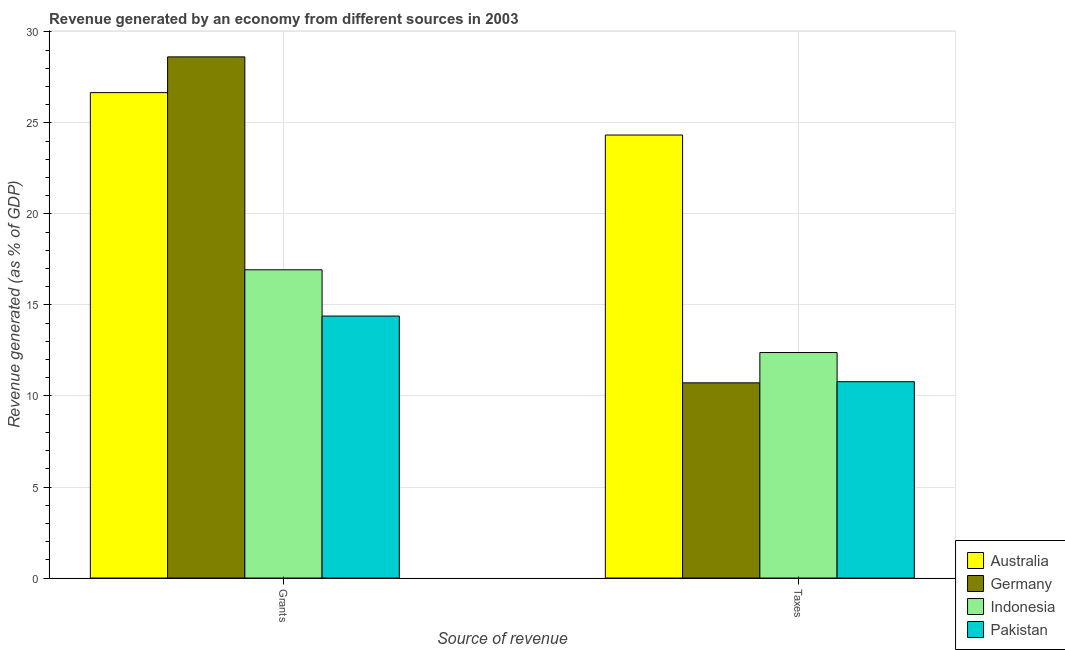How many different coloured bars are there?
Your response must be concise. 4. How many bars are there on the 1st tick from the right?
Make the answer very short. 4. What is the label of the 1st group of bars from the left?
Offer a terse response. Grants. What is the revenue generated by grants in Germany?
Make the answer very short. 28.62. Across all countries, what is the maximum revenue generated by grants?
Offer a very short reply. 28.62. Across all countries, what is the minimum revenue generated by taxes?
Your response must be concise. 10.72. In which country was the revenue generated by grants maximum?
Your response must be concise. Germany. In which country was the revenue generated by taxes minimum?
Provide a short and direct response. Germany. What is the total revenue generated by taxes in the graph?
Make the answer very short. 58.22. What is the difference between the revenue generated by taxes in Germany and that in Pakistan?
Keep it short and to the point. -0.06. What is the difference between the revenue generated by grants in Germany and the revenue generated by taxes in Indonesia?
Your answer should be very brief. 16.24. What is the average revenue generated by taxes per country?
Provide a short and direct response. 14.56. What is the difference between the revenue generated by grants and revenue generated by taxes in Pakistan?
Ensure brevity in your answer.  3.61. In how many countries, is the revenue generated by taxes greater than 16 %?
Offer a terse response. 1. What is the ratio of the revenue generated by taxes in Pakistan to that in Indonesia?
Give a very brief answer. 0.87. In how many countries, is the revenue generated by grants greater than the average revenue generated by grants taken over all countries?
Ensure brevity in your answer.  2. What does the 3rd bar from the left in Grants represents?
Offer a terse response. Indonesia. Are all the bars in the graph horizontal?
Your answer should be compact. No. Are the values on the major ticks of Y-axis written in scientific E-notation?
Provide a succinct answer. No. Does the graph contain any zero values?
Give a very brief answer. No. Does the graph contain grids?
Your answer should be compact. Yes. What is the title of the graph?
Provide a short and direct response. Revenue generated by an economy from different sources in 2003. What is the label or title of the X-axis?
Ensure brevity in your answer.  Source of revenue. What is the label or title of the Y-axis?
Provide a short and direct response. Revenue generated (as % of GDP). What is the Revenue generated (as % of GDP) in Australia in Grants?
Give a very brief answer. 26.66. What is the Revenue generated (as % of GDP) in Germany in Grants?
Your answer should be compact. 28.62. What is the Revenue generated (as % of GDP) in Indonesia in Grants?
Your answer should be very brief. 16.93. What is the Revenue generated (as % of GDP) of Pakistan in Grants?
Provide a short and direct response. 14.39. What is the Revenue generated (as % of GDP) of Australia in Taxes?
Provide a succinct answer. 24.33. What is the Revenue generated (as % of GDP) in Germany in Taxes?
Your answer should be compact. 10.72. What is the Revenue generated (as % of GDP) of Indonesia in Taxes?
Make the answer very short. 12.39. What is the Revenue generated (as % of GDP) in Pakistan in Taxes?
Give a very brief answer. 10.78. Across all Source of revenue, what is the maximum Revenue generated (as % of GDP) in Australia?
Ensure brevity in your answer.  26.66. Across all Source of revenue, what is the maximum Revenue generated (as % of GDP) of Germany?
Give a very brief answer. 28.62. Across all Source of revenue, what is the maximum Revenue generated (as % of GDP) in Indonesia?
Your answer should be compact. 16.93. Across all Source of revenue, what is the maximum Revenue generated (as % of GDP) in Pakistan?
Offer a very short reply. 14.39. Across all Source of revenue, what is the minimum Revenue generated (as % of GDP) in Australia?
Your answer should be very brief. 24.33. Across all Source of revenue, what is the minimum Revenue generated (as % of GDP) of Germany?
Keep it short and to the point. 10.72. Across all Source of revenue, what is the minimum Revenue generated (as % of GDP) of Indonesia?
Keep it short and to the point. 12.39. Across all Source of revenue, what is the minimum Revenue generated (as % of GDP) in Pakistan?
Keep it short and to the point. 10.78. What is the total Revenue generated (as % of GDP) of Australia in the graph?
Provide a short and direct response. 50.99. What is the total Revenue generated (as % of GDP) in Germany in the graph?
Your answer should be compact. 39.35. What is the total Revenue generated (as % of GDP) of Indonesia in the graph?
Provide a succinct answer. 29.32. What is the total Revenue generated (as % of GDP) of Pakistan in the graph?
Offer a very short reply. 25.17. What is the difference between the Revenue generated (as % of GDP) of Australia in Grants and that in Taxes?
Provide a succinct answer. 2.33. What is the difference between the Revenue generated (as % of GDP) of Germany in Grants and that in Taxes?
Make the answer very short. 17.9. What is the difference between the Revenue generated (as % of GDP) of Indonesia in Grants and that in Taxes?
Provide a succinct answer. 4.54. What is the difference between the Revenue generated (as % of GDP) of Pakistan in Grants and that in Taxes?
Offer a very short reply. 3.61. What is the difference between the Revenue generated (as % of GDP) of Australia in Grants and the Revenue generated (as % of GDP) of Germany in Taxes?
Offer a very short reply. 15.94. What is the difference between the Revenue generated (as % of GDP) in Australia in Grants and the Revenue generated (as % of GDP) in Indonesia in Taxes?
Offer a very short reply. 14.28. What is the difference between the Revenue generated (as % of GDP) in Australia in Grants and the Revenue generated (as % of GDP) in Pakistan in Taxes?
Your response must be concise. 15.88. What is the difference between the Revenue generated (as % of GDP) in Germany in Grants and the Revenue generated (as % of GDP) in Indonesia in Taxes?
Give a very brief answer. 16.24. What is the difference between the Revenue generated (as % of GDP) in Germany in Grants and the Revenue generated (as % of GDP) in Pakistan in Taxes?
Provide a succinct answer. 17.84. What is the difference between the Revenue generated (as % of GDP) in Indonesia in Grants and the Revenue generated (as % of GDP) in Pakistan in Taxes?
Provide a succinct answer. 6.15. What is the average Revenue generated (as % of GDP) of Australia per Source of revenue?
Provide a short and direct response. 25.5. What is the average Revenue generated (as % of GDP) in Germany per Source of revenue?
Offer a very short reply. 19.67. What is the average Revenue generated (as % of GDP) of Indonesia per Source of revenue?
Ensure brevity in your answer.  14.66. What is the average Revenue generated (as % of GDP) of Pakistan per Source of revenue?
Offer a very short reply. 12.59. What is the difference between the Revenue generated (as % of GDP) of Australia and Revenue generated (as % of GDP) of Germany in Grants?
Your response must be concise. -1.96. What is the difference between the Revenue generated (as % of GDP) in Australia and Revenue generated (as % of GDP) in Indonesia in Grants?
Give a very brief answer. 9.73. What is the difference between the Revenue generated (as % of GDP) of Australia and Revenue generated (as % of GDP) of Pakistan in Grants?
Provide a succinct answer. 12.27. What is the difference between the Revenue generated (as % of GDP) of Germany and Revenue generated (as % of GDP) of Indonesia in Grants?
Your answer should be very brief. 11.69. What is the difference between the Revenue generated (as % of GDP) of Germany and Revenue generated (as % of GDP) of Pakistan in Grants?
Your answer should be compact. 14.23. What is the difference between the Revenue generated (as % of GDP) in Indonesia and Revenue generated (as % of GDP) in Pakistan in Grants?
Your response must be concise. 2.54. What is the difference between the Revenue generated (as % of GDP) in Australia and Revenue generated (as % of GDP) in Germany in Taxes?
Keep it short and to the point. 13.61. What is the difference between the Revenue generated (as % of GDP) in Australia and Revenue generated (as % of GDP) in Indonesia in Taxes?
Your answer should be compact. 11.95. What is the difference between the Revenue generated (as % of GDP) in Australia and Revenue generated (as % of GDP) in Pakistan in Taxes?
Your response must be concise. 13.55. What is the difference between the Revenue generated (as % of GDP) in Germany and Revenue generated (as % of GDP) in Indonesia in Taxes?
Your answer should be compact. -1.66. What is the difference between the Revenue generated (as % of GDP) in Germany and Revenue generated (as % of GDP) in Pakistan in Taxes?
Ensure brevity in your answer.  -0.06. What is the difference between the Revenue generated (as % of GDP) of Indonesia and Revenue generated (as % of GDP) of Pakistan in Taxes?
Provide a short and direct response. 1.6. What is the ratio of the Revenue generated (as % of GDP) of Australia in Grants to that in Taxes?
Give a very brief answer. 1.1. What is the ratio of the Revenue generated (as % of GDP) of Germany in Grants to that in Taxes?
Make the answer very short. 2.67. What is the ratio of the Revenue generated (as % of GDP) of Indonesia in Grants to that in Taxes?
Provide a short and direct response. 1.37. What is the ratio of the Revenue generated (as % of GDP) of Pakistan in Grants to that in Taxes?
Keep it short and to the point. 1.33. What is the difference between the highest and the second highest Revenue generated (as % of GDP) of Australia?
Offer a very short reply. 2.33. What is the difference between the highest and the second highest Revenue generated (as % of GDP) of Germany?
Make the answer very short. 17.9. What is the difference between the highest and the second highest Revenue generated (as % of GDP) in Indonesia?
Offer a terse response. 4.54. What is the difference between the highest and the second highest Revenue generated (as % of GDP) of Pakistan?
Your response must be concise. 3.61. What is the difference between the highest and the lowest Revenue generated (as % of GDP) of Australia?
Your answer should be very brief. 2.33. What is the difference between the highest and the lowest Revenue generated (as % of GDP) in Germany?
Offer a terse response. 17.9. What is the difference between the highest and the lowest Revenue generated (as % of GDP) of Indonesia?
Provide a succinct answer. 4.54. What is the difference between the highest and the lowest Revenue generated (as % of GDP) in Pakistan?
Make the answer very short. 3.61. 